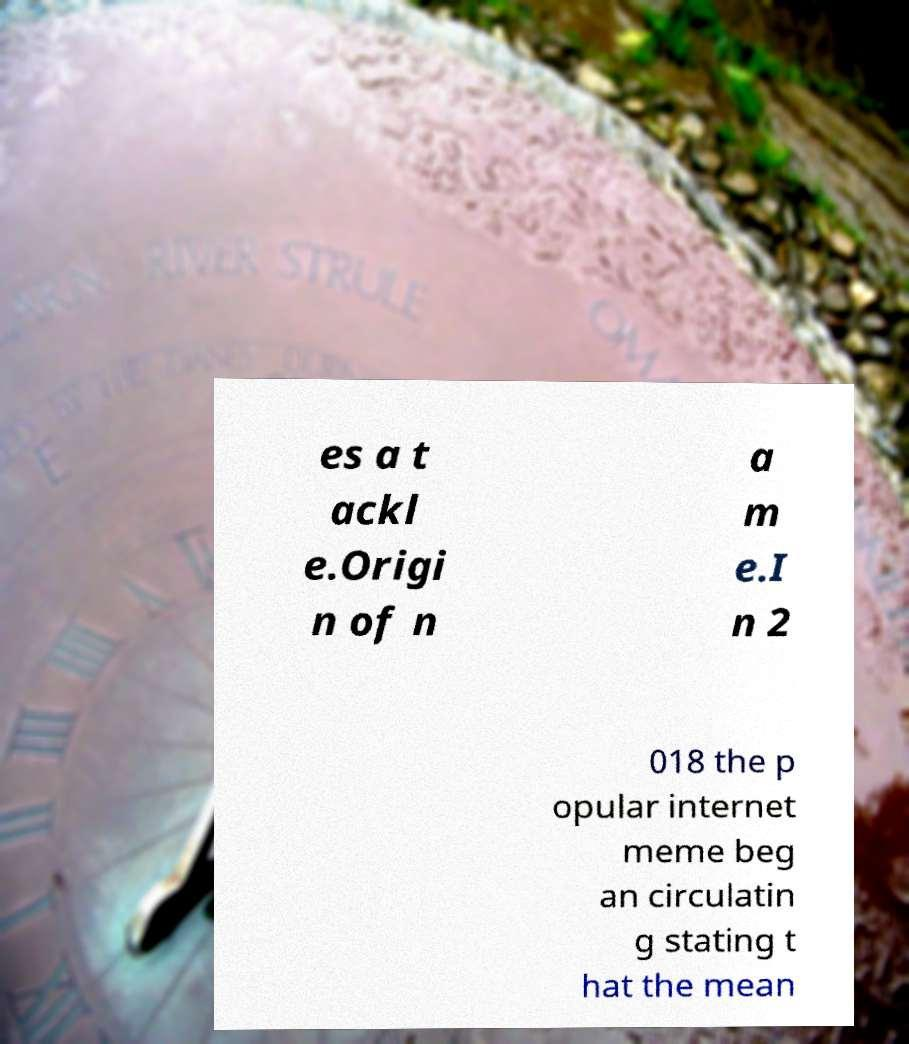Could you assist in decoding the text presented in this image and type it out clearly? es a t ackl e.Origi n of n a m e.I n 2 018 the p opular internet meme beg an circulatin g stating t hat the mean 